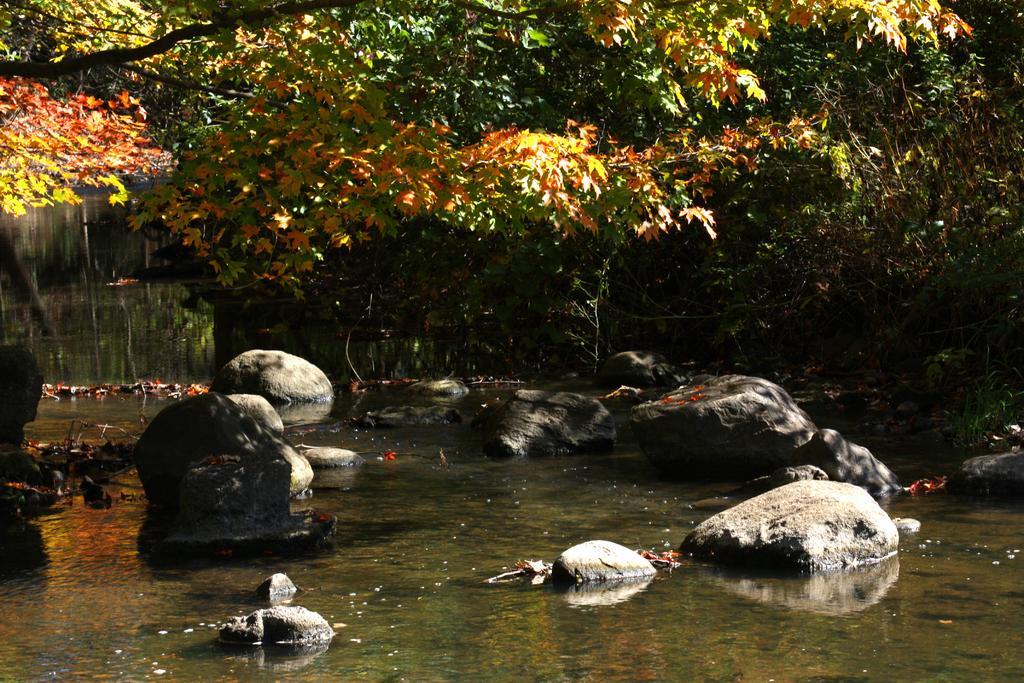Describe this image in one or two sentences. In this picture we can see stones, leaves on the water and in the background we can see trees. 